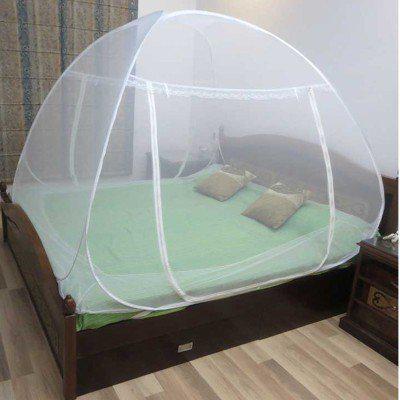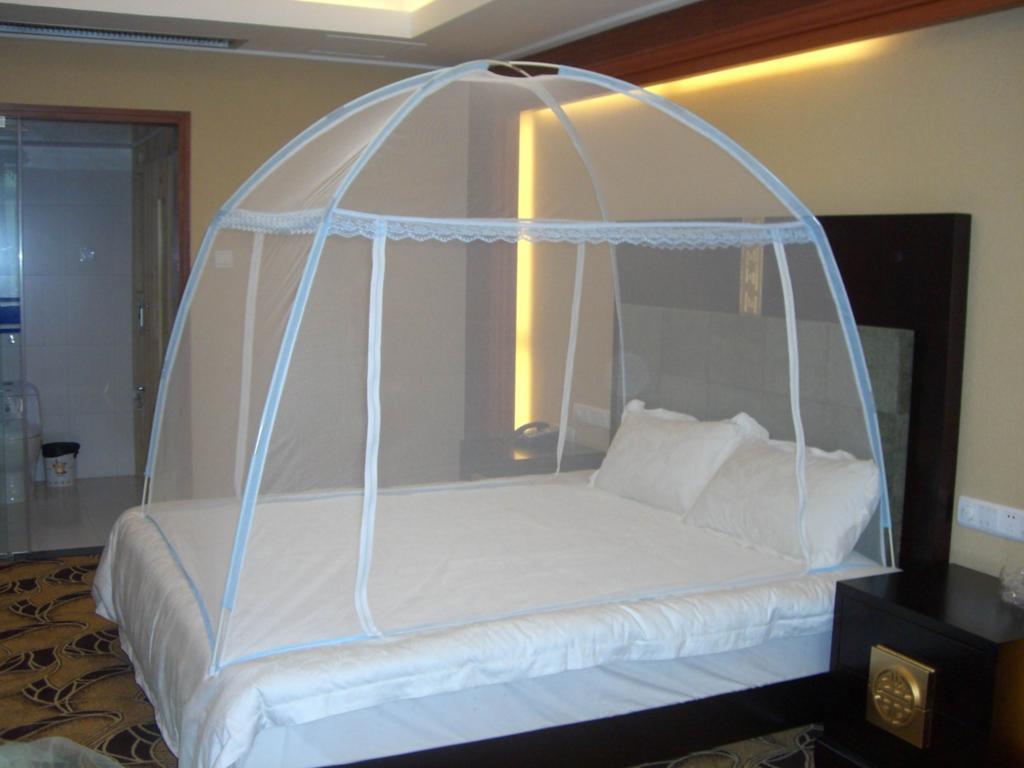The first image is the image on the left, the second image is the image on the right. For the images shown, is this caption "There is a round tent and a square tent." true? Answer yes or no. No. 